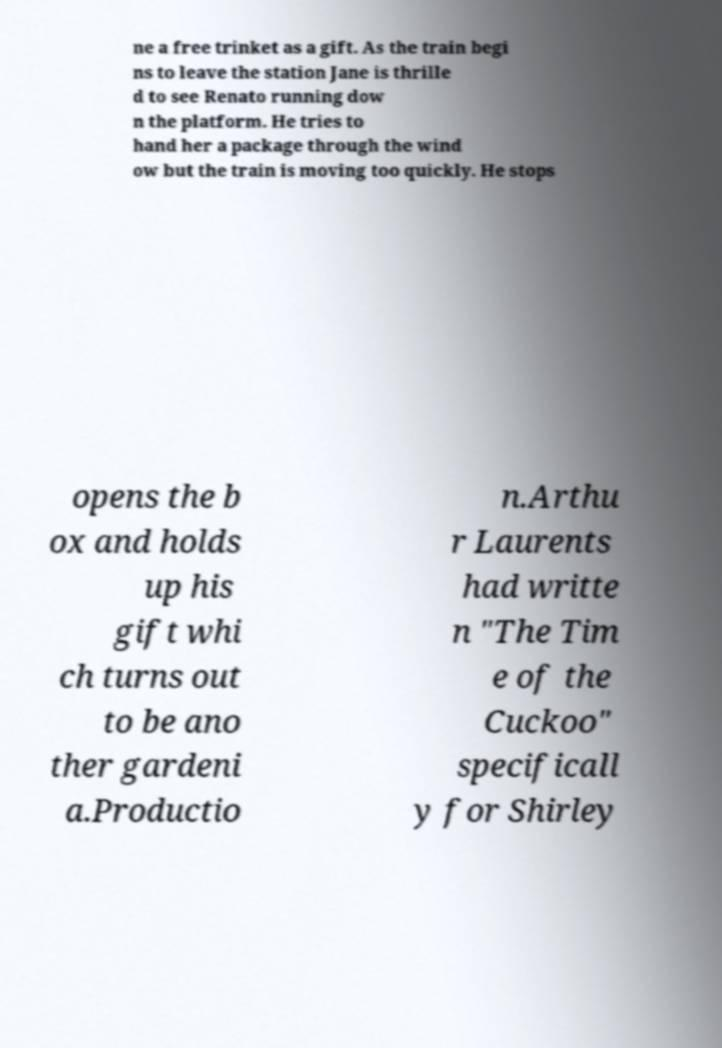Please identify and transcribe the text found in this image. ne a free trinket as a gift. As the train begi ns to leave the station Jane is thrille d to see Renato running dow n the platform. He tries to hand her a package through the wind ow but the train is moving too quickly. He stops opens the b ox and holds up his gift whi ch turns out to be ano ther gardeni a.Productio n.Arthu r Laurents had writte n "The Tim e of the Cuckoo" specificall y for Shirley 